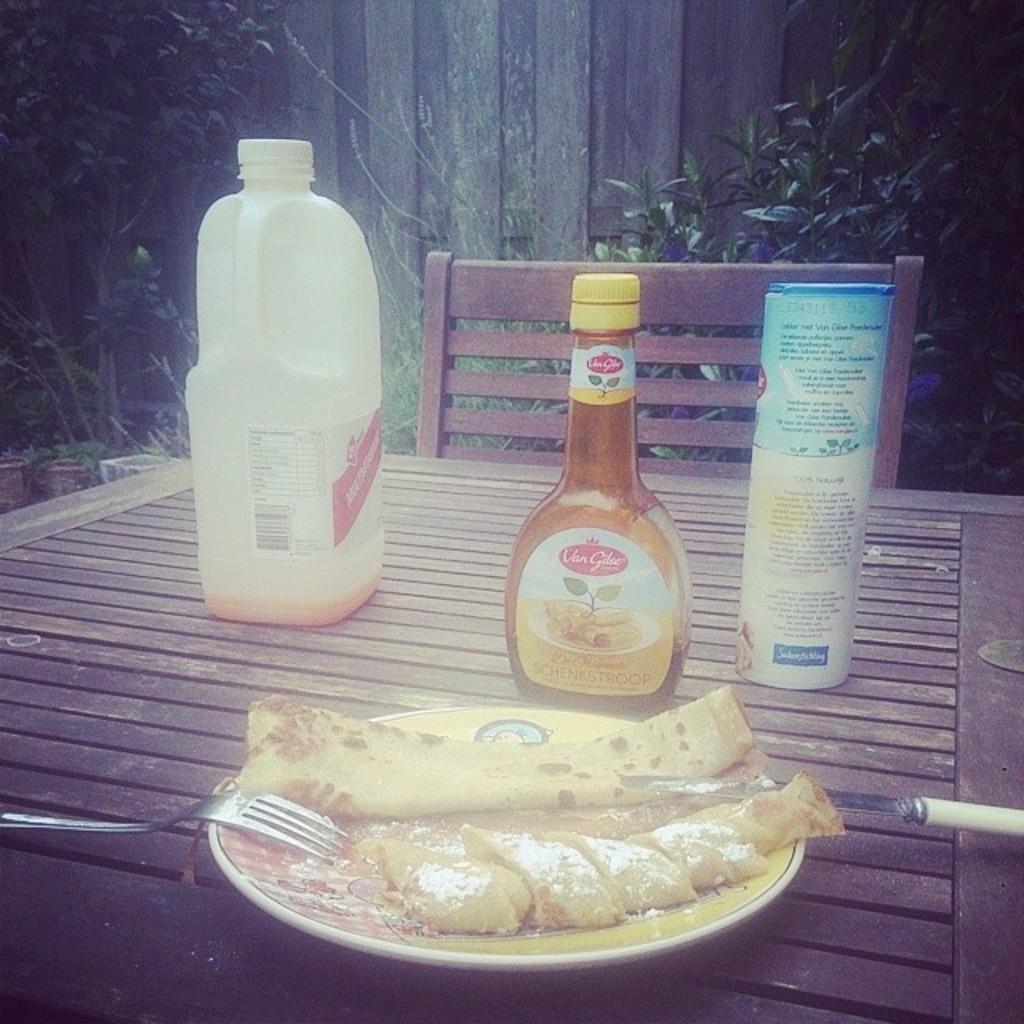How would you summarize this image in a sentence or two? In this image, there is a table in front of this chair. This table contains bottles, plate, knife and fork. There is a plant behind this table. There is a food on the table. 